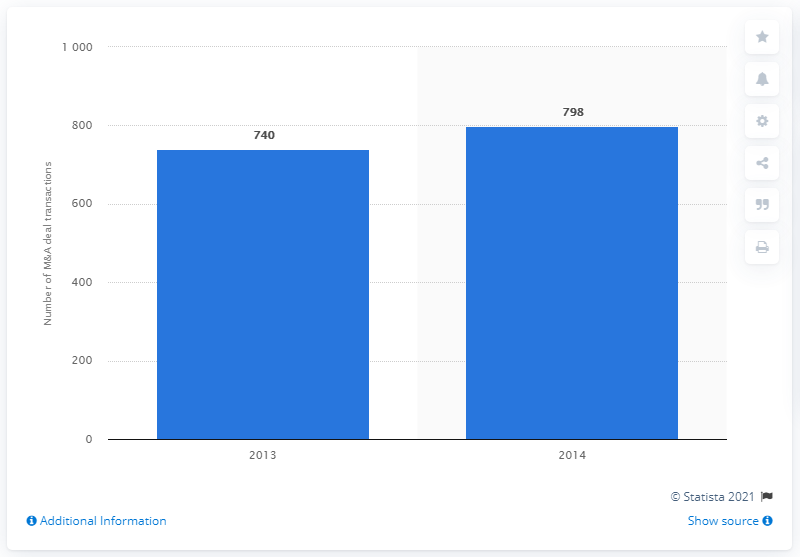Can you explain the trend in the number of mergers and acquisitions from 2013 to 2014 shown in this chart? The chart shows a growing trend in mergers and acquisitions between 2013 and 2014. Specifically, there was an increase from 740 transactions in 2013 to 798 in 2014, which suggests a growing economic or strategic interest in consolidations within that period. 